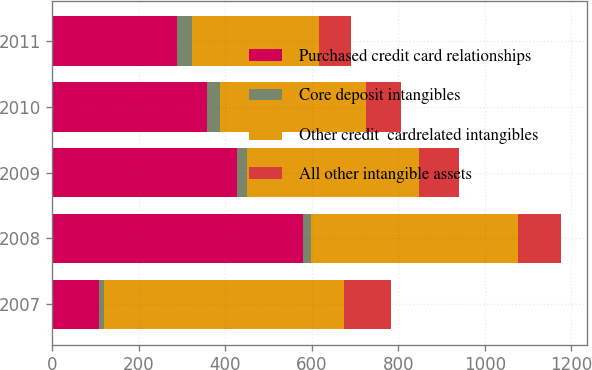<chart> <loc_0><loc_0><loc_500><loc_500><stacked_bar_chart><ecel><fcel>2007<fcel>2008<fcel>2009<fcel>2010<fcel>2011<nl><fcel>Purchased credit card relationships<fcel>109<fcel>580<fcel>428<fcel>358<fcel>289<nl><fcel>Core deposit intangibles<fcel>10<fcel>17<fcel>23<fcel>30<fcel>35<nl><fcel>Other credit  cardrelated intangibles<fcel>555<fcel>479<fcel>397<fcel>336<fcel>293<nl><fcel>All other intangible assets<fcel>109<fcel>100<fcel>92<fcel>81<fcel>73<nl></chart> 